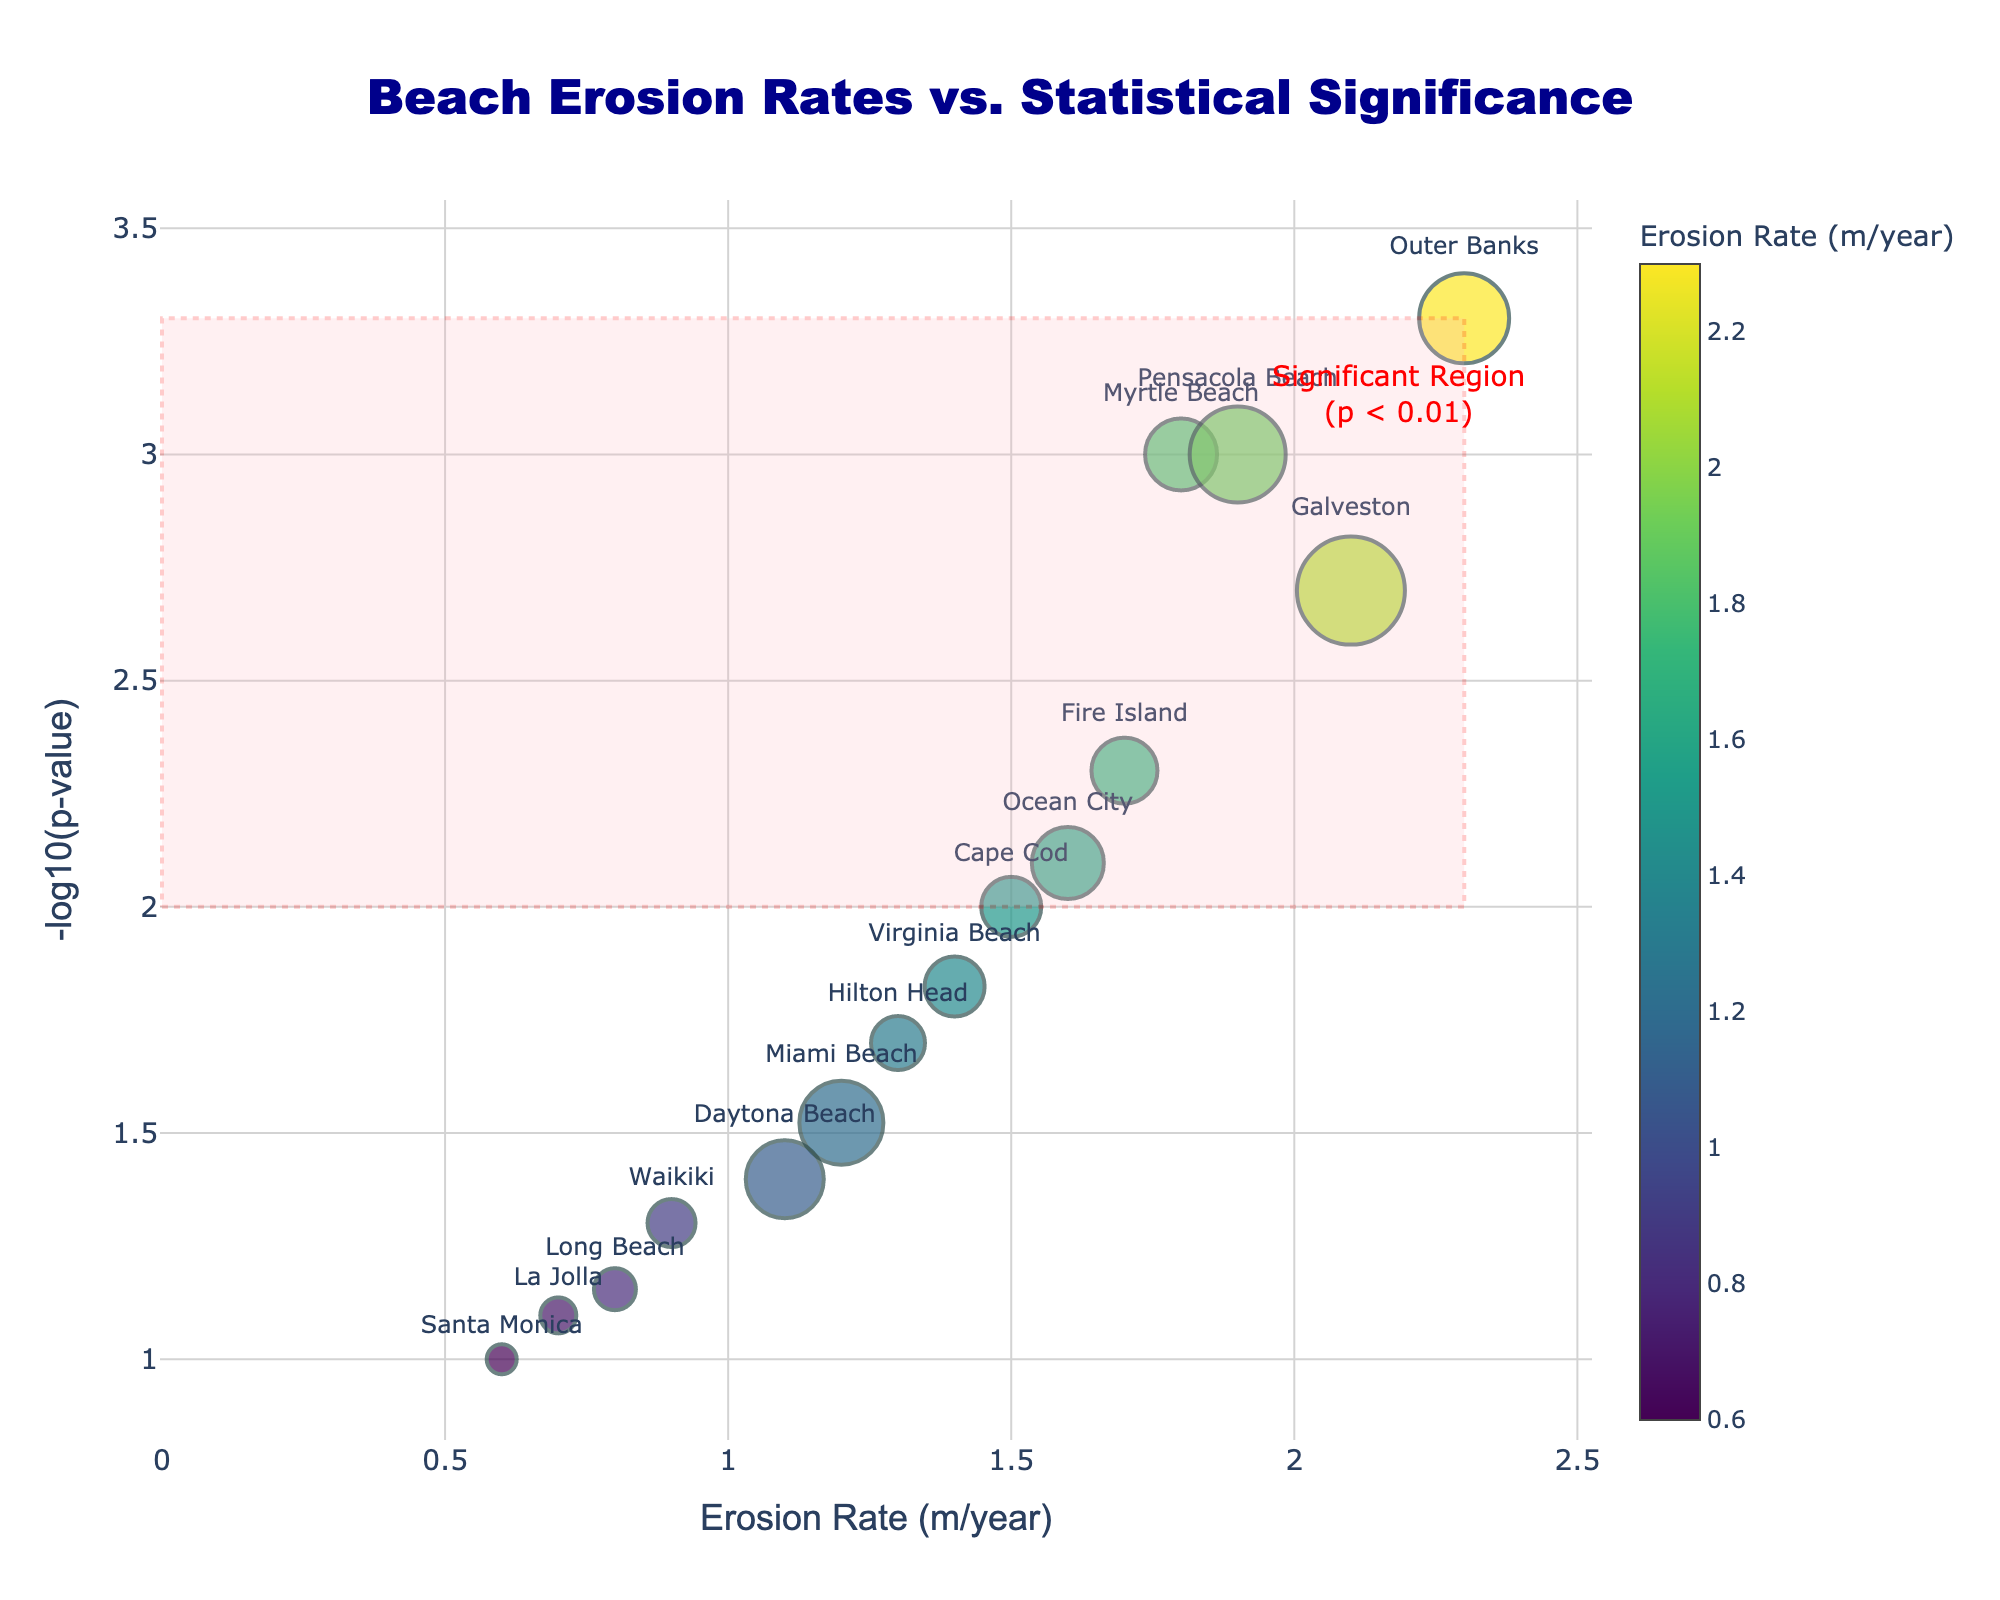What is the title of the figure? The title is clearly displayed at the top of the figure and reads, "Beach Erosion Rates vs. Statistical Significance."
Answer: Beach Erosion Rates vs. Statistical Significance What does the x-axis represent? The x-axis label indicates that it represents the "Erosion Rate (m/year)."
Answer: Erosion Rate (m/year) What does the y-axis represent? The y-axis label shows that it represents "-log10(p-value)."
Answer: -log10(p-value) How many beaches are represented in the plot? Each marker on the plot represents a beach, and there are 15 markers in total.
Answer: 15 Which beach has the highest erosion rate? By looking at the x-axis values, we can see that "Outer Banks" has the highest erosion rate of 2.3 m/year.
Answer: Outer Banks Which beach has the smallest p-value? Since a smaller p-value translates to a higher value on the y-axis (-log10(p-value)), "Outer Banks" also has the smallest p-value of 0.0005.
Answer: Outer Banks Which beaches fall into the significant region (p < 0.01)? The significant region is highlighted in the figure. The beaches within this region are Myrtle Beach, Outer Banks, Galveston, Pensacola Beach, and Fire Island.
Answer: Myrtle Beach, Outer Banks, Galveston, Pensacola Beach, Fire Island How does the Extreme Weather Event Frequency relate to the marker size? The figure's legend or description states that marker size increases with the frequency of extreme weather events.
Answer: Increases with frequency Which area has the highest frequency of extreme weather events? The marker with the largest size, which represents the highest frequency of extreme weather events, belongs to Galveston with a frequency of 18 events.
Answer: Galveston Compare the erosion rates of Miami Beach and Virginia Beach. Which one is higher, and by how much? By locating Miami Beach and Virginia Beach on the x-axis, Miami Beach has an erosion rate of 1.2 m/year, and Virginia Beach has 1.4 m/year. Thus, Virginia Beach's rate is 0.2 m/year higher.
Answer: Virginia Beach by 0.2 m/year 